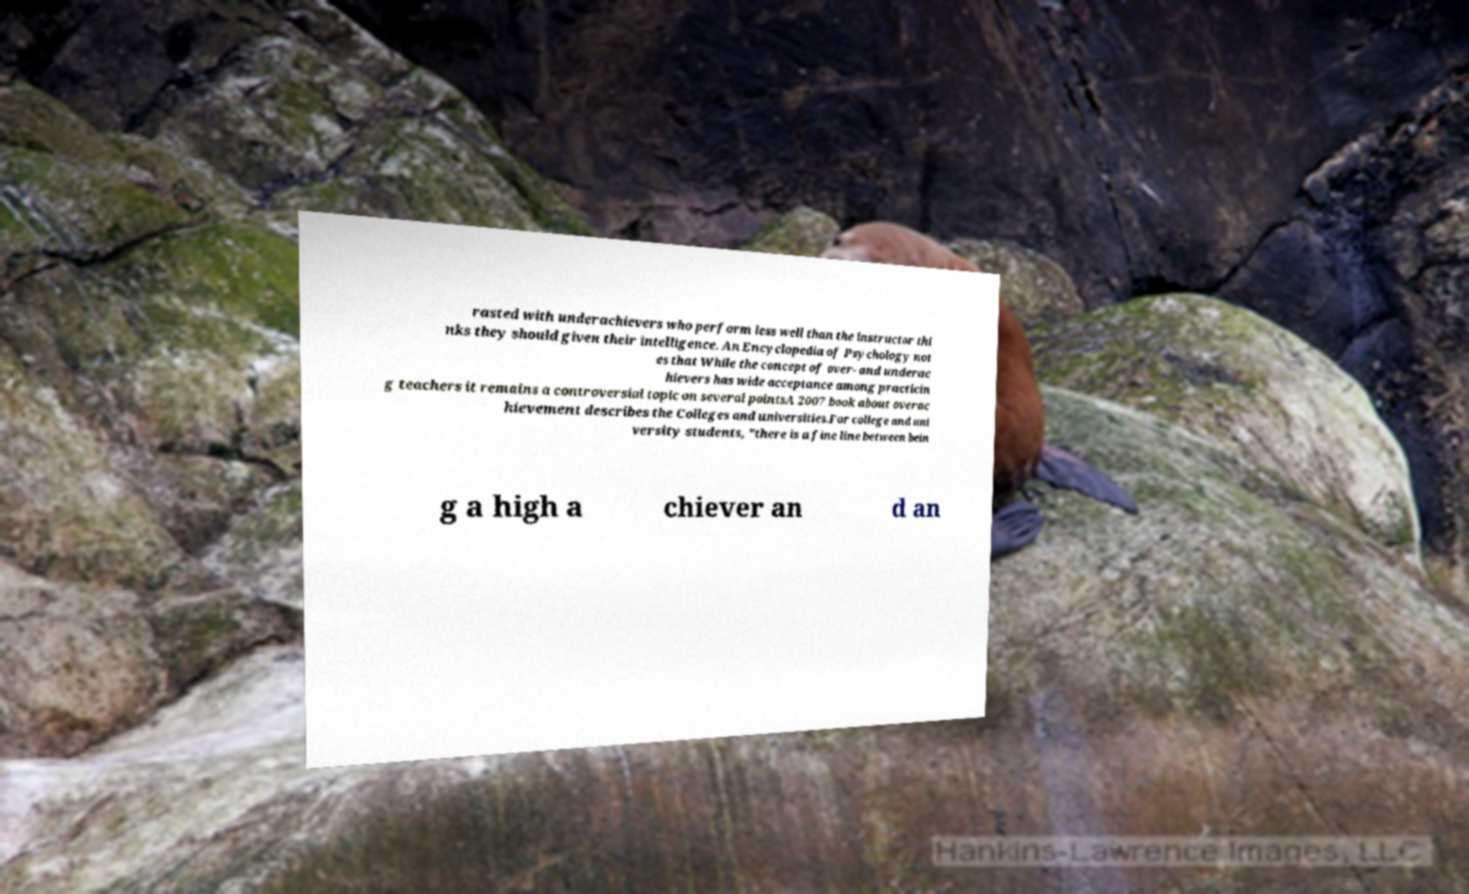There's text embedded in this image that I need extracted. Can you transcribe it verbatim? rasted with underachievers who perform less well than the instructor thi nks they should given their intelligence. An Encyclopedia of Psychology not es that While the concept of over- and underac hievers has wide acceptance among practicin g teachers it remains a controversial topic on several pointsA 2007 book about overac hievement describes the Colleges and universities.For college and uni versity students, "there is a fine line between bein g a high a chiever an d an 